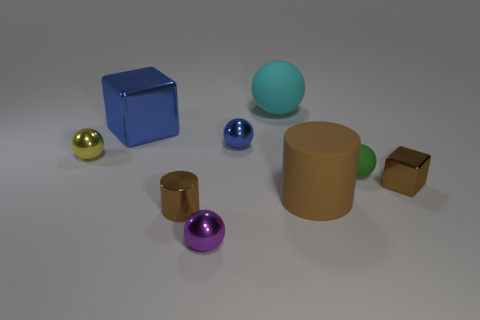Does the purple shiny object have the same shape as the brown matte thing?
Your response must be concise. No. What number of small things are purple things or brown matte cylinders?
Keep it short and to the point. 1. What is the color of the rubber cylinder?
Offer a terse response. Brown. There is a object behind the metallic block behind the tiny cube; what shape is it?
Make the answer very short. Sphere. Are there any tiny purple blocks that have the same material as the tiny brown block?
Provide a succinct answer. No. There is a matte sphere behind the yellow metal object; is its size the same as the yellow metal thing?
Give a very brief answer. No. What number of brown objects are either big matte spheres or cylinders?
Provide a short and direct response. 2. There is a small sphere behind the yellow thing; what is its material?
Offer a very short reply. Metal. How many tiny yellow metallic objects are to the left of the small brown metal thing that is to the right of the cyan rubber object?
Your response must be concise. 1. How many small brown things have the same shape as the big shiny object?
Keep it short and to the point. 1. 